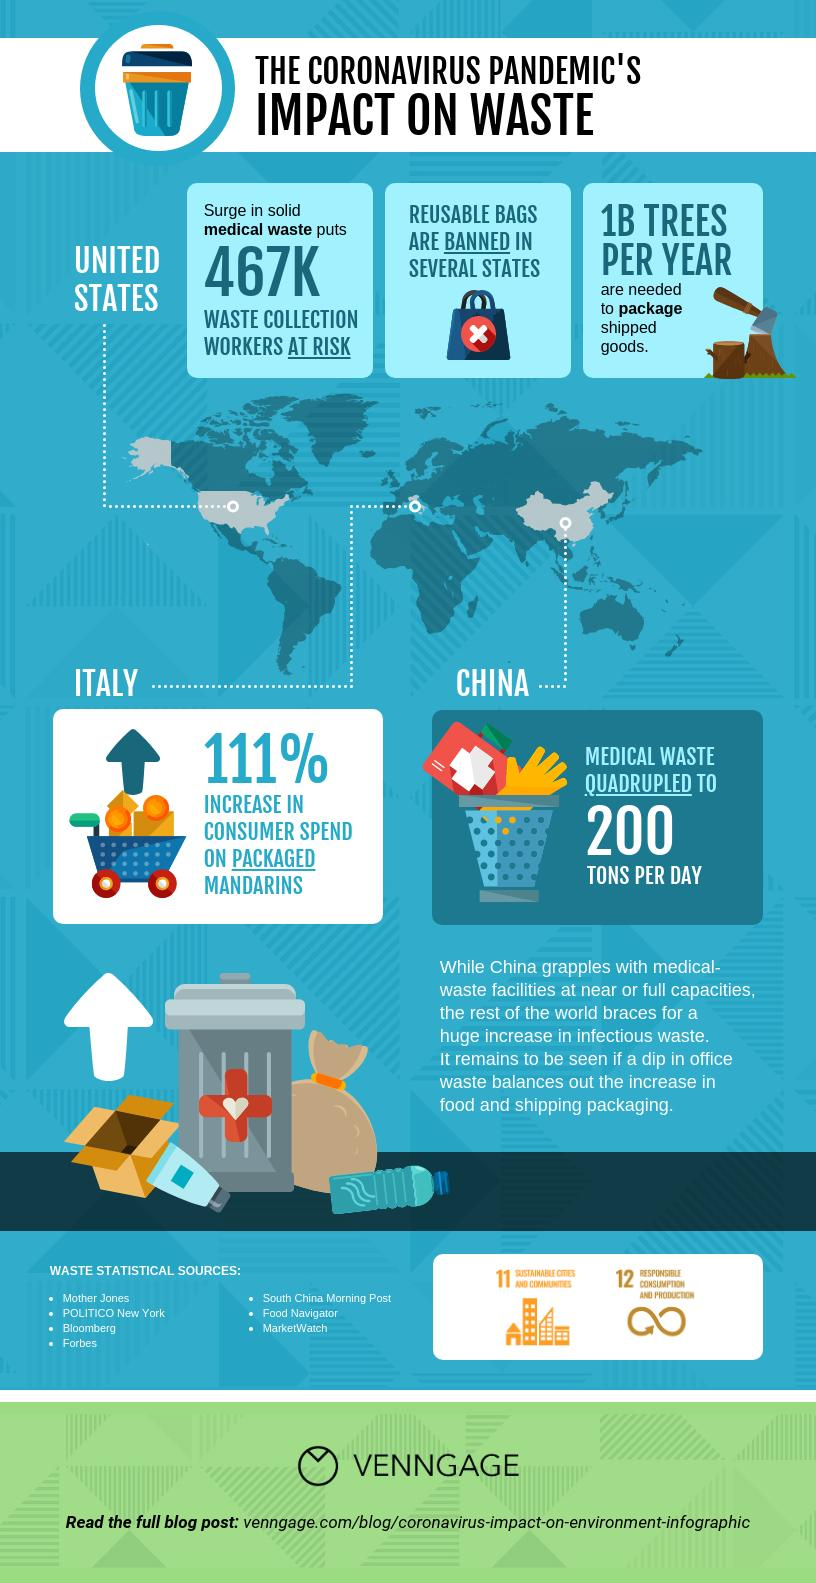Indicate a few pertinent items in this graphic. There are 7 statistical sources of waste. 